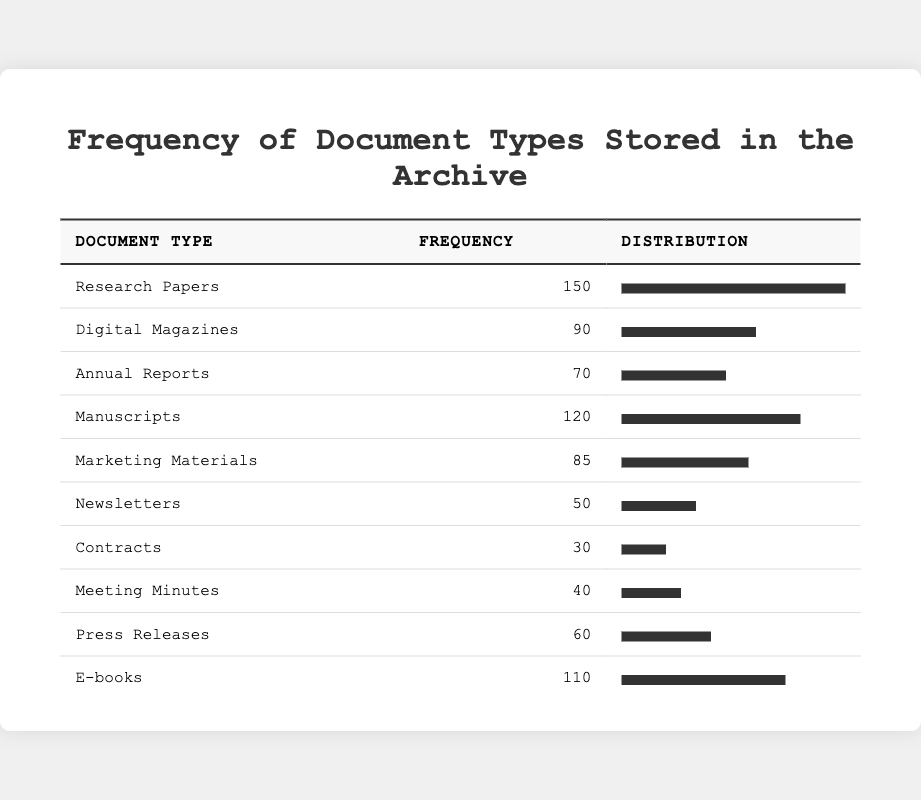What is the frequency of Research Papers stored in the archive? The frequency for Research Papers is listed in the table under the corresponding column, which states it is 150.
Answer: 150 How many Digital Magazines are stored in the archive? The frequency of Digital Magazines can be found directly in the table, which shows 90 under the frequency column.
Answer: 90 Which document type has the highest frequency? By comparing the frequency values in the table, Research Papers at 150 has the highest frequency compared to all other document types.
Answer: Research Papers Is the frequency of Newsletters greater than that of Contracts? The frequency of Newsletters is 50 and that of Contracts is 30. 50 is greater than 30, making the statement true.
Answer: Yes What is the total frequency of E-books and Digital Magazines combined? The frequency for E-books is 110 and for Digital Magazines is 90. Adding these two numbers (110 + 90) gives us 200.
Answer: 200 How many document types have a frequency greater than 80? The document types with frequencies greater than 80 are Research Papers (150), Manuscripts (120), E-books (110), and Digital Magazines (90). There are 4 types in total.
Answer: 4 What is the average frequency of the document types stored in the archive? To find the average, first, sum all frequencies: 150 + 90 + 70 + 120 + 85 + 50 + 30 + 40 + 60 + 110 = 855. Then divide by the number of document types (10), giving an average of 85.5.
Answer: 85.5 Are there more than 100 E-books stored in the archive? The frequency of E-books is 110, which is greater than 100. Thus, the answer is true.
Answer: Yes What is the difference in frequency between the highest and lowest stored document types? The highest frequency is for Research Papers at 150, and the lowest is for Contracts at 30. The difference is 150 - 30 = 120.
Answer: 120 Which document type has a frequency that is more than 30 but less than 50? By scanning through the table, Meeting Minutes (40) and Press Releases (60) fall under the range, but only Meeting Minutes fits the criteria of having a frequency greater than 30 and less than 50.
Answer: Meeting Minutes 